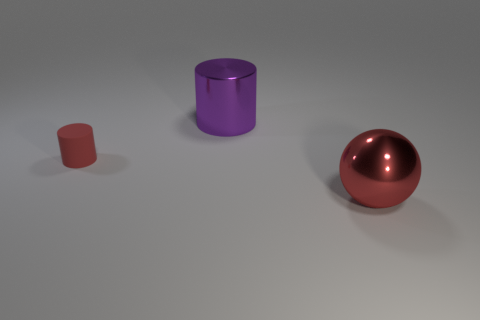What is the shape of the shiny thing that is the same color as the rubber thing?
Offer a very short reply. Sphere. There is a object that is right of the red cylinder and behind the large red thing; what size is it?
Provide a short and direct response. Large. Are there any green cylinders that have the same size as the sphere?
Offer a very short reply. No. Is the number of small objects on the left side of the red rubber object greater than the number of large metallic spheres left of the large purple thing?
Offer a terse response. No. Is the ball made of the same material as the red thing behind the large ball?
Your answer should be compact. No. How many tiny red rubber cylinders are in front of the cylinder that is behind the red thing that is left of the large red metal ball?
Provide a short and direct response. 1. Does the small rubber object have the same shape as the big object behind the tiny rubber object?
Provide a short and direct response. Yes. There is a object that is both in front of the large purple metal cylinder and behind the big red shiny thing; what is its color?
Keep it short and to the point. Red. What is the red object that is behind the large object that is in front of the red object that is behind the red shiny ball made of?
Offer a terse response. Rubber. What material is the ball?
Offer a very short reply. Metal. 